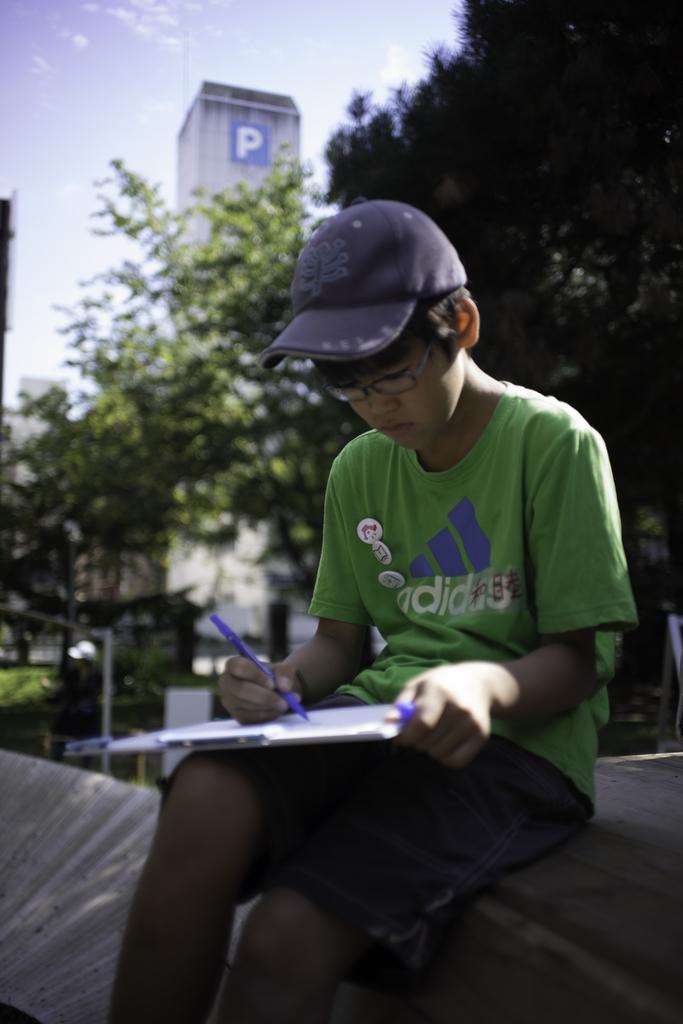Describe this image in one or two sentences. In the center of the image we can see one boy sitting and holding a pen, book and plank. And he is wearing a cap. In the background, we can see the sky, clouds, trees, grass, one tower, banner, pole and a few other objects. 